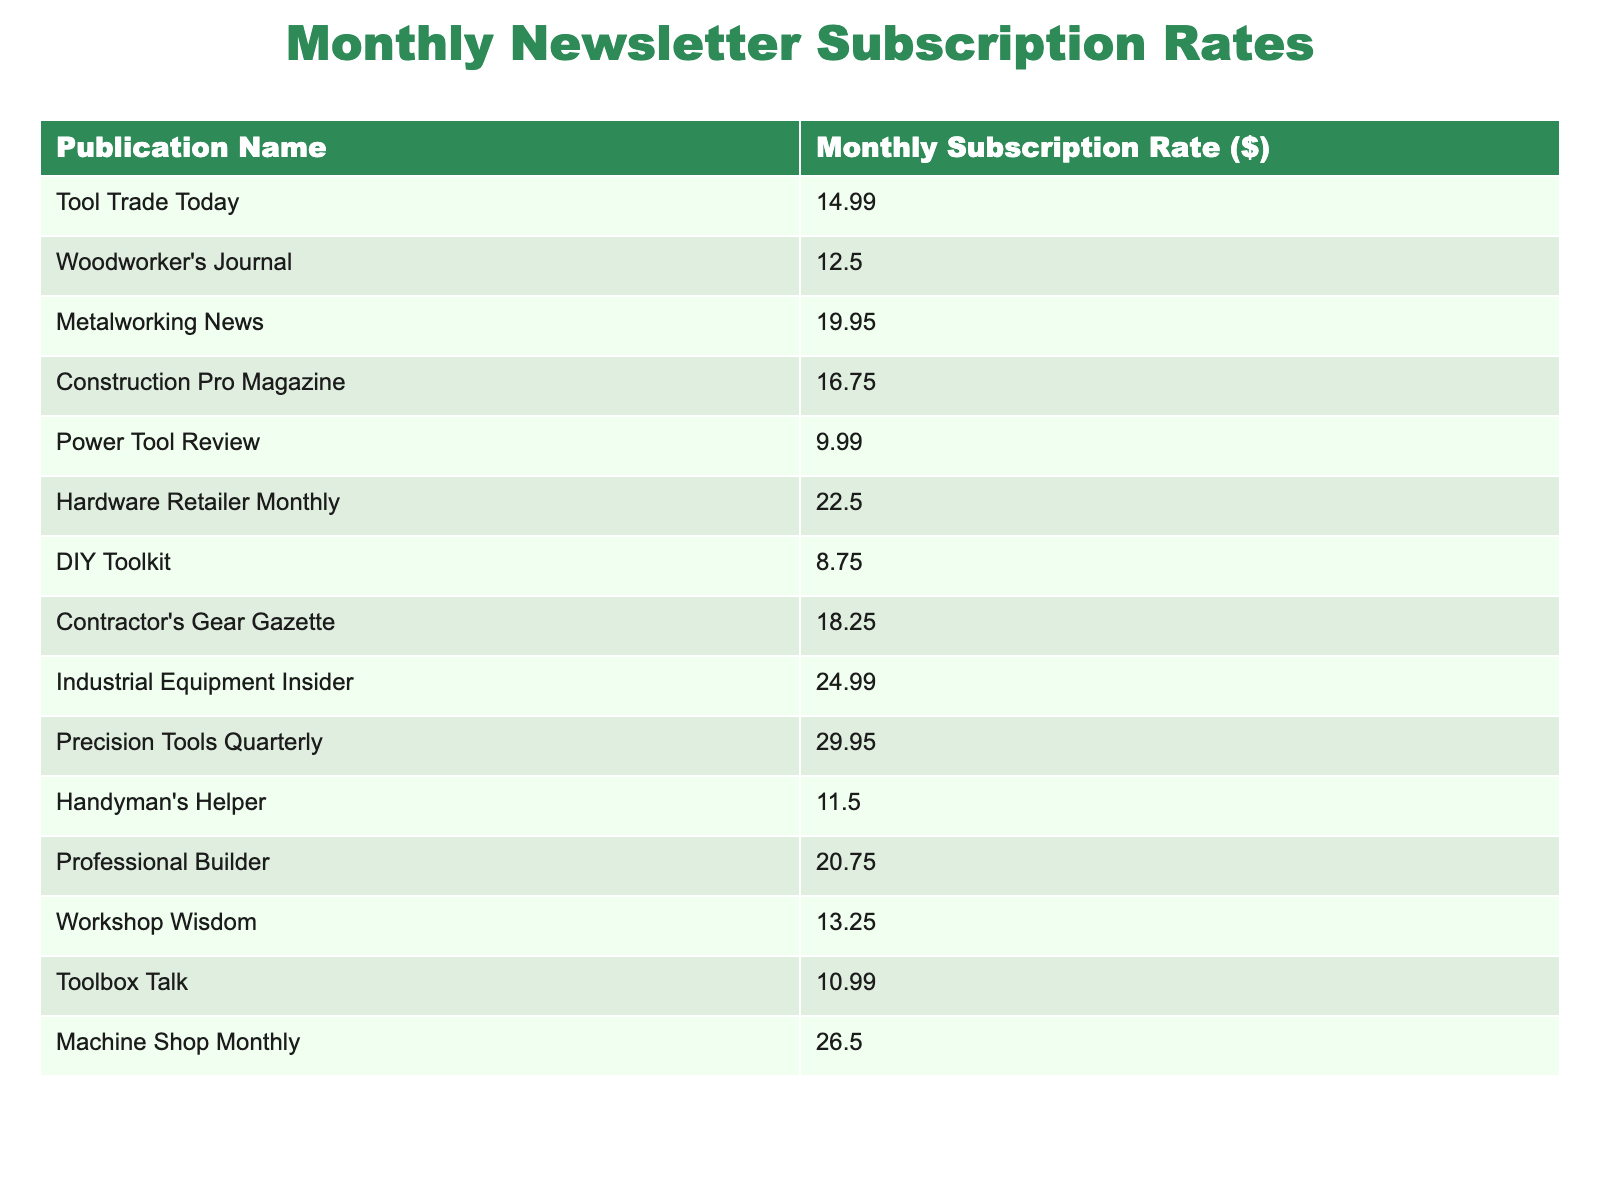What is the subscription rate for Tool Trade Today? The table lists the subscription rates for various publications, and Tool Trade Today's rate is specifically shown in the first row.
Answer: 14.99 Which publication has the highest monthly subscription rate? To determine this, I will look through the subscription rates and find the maximum value. The rate for Precision Tools Quarterly is 29.95, which is higher than all others.
Answer: 29.95 How much does a subscription to DIY Toolkit cost? The table provides the subscription rate for DIY Toolkit directly in the corresponding row, which is listed as 8.75.
Answer: 8.75 What is the average subscription rate for all publications listed? First, I will sum all the subscription rates: 14.99 + 12.50 + 19.95 + 16.75 + 9.99 + 22.50 + 8.75 + 18.25 + 24.99 + 29.95 + 11.50 + 20.75 + 13.25 + 10.99 + 26.50 =  340.48. There are 15 publications, so I divide the total by 15, which gives approximately 22.70.
Answer: 22.70 Is the monthly subscription rate for Hardware Retailer Monthly less than $20? By locating Hardware Retailer Monthly in the table, I see its subscription rate is 22.50, which is greater than 20.
Answer: No What is the total subscription rate for the two most expensive publications? The two most expensive publications are Precision Tools Quarterly (29.95) and Industrial Equipment Insider (24.99). Their total is 29.95 + 24.99 = 54.94.
Answer: 54.94 How many publications have a subscription rate greater than $15? I will examine each rate in the table to count how many are above $15. The publications with rates greater than $15 are Metalworking News, Construction Pro Magazine, Hardware Retailer Monthly, Contractor's Gear Gazette, Professional Builder, Machine Shop Monthly, and Precision Tools Quarterly. This gives a total of 7.
Answer: 7 What is the difference between the lowest and highest subscription rates? The lowest subscription rate is for DIY Toolkit at 8.75, and the highest is for Precision Tools Quarterly at 29.95. The difference is calculated as 29.95 - 8.75 = 21.20.
Answer: 21.20 Which publication has a subscription rate closest to $15? To find which subscription rate is closest to $15, I will compare all the rates to 15. The closest rates are Woodworker's Journal at 12.50 and Toolbox Talk at 10.99, but Woodworker's Journal is closer because the difference (2.50) is less than Toolbox Talk (4.01).
Answer: Woodworker's Journal How many publications have a subscription rate between $10 and $20? I will check the table for rates that fall between $10 and $20. The rates that fit this condition are Tool Trade Today, Woodworker's Journal, Construction Pro Magazine, Power Tool Review, Contractor's Gear Gazette, Handyman's Helper, and Workshop Wisdom, totaling 7 publications.
Answer: 7 